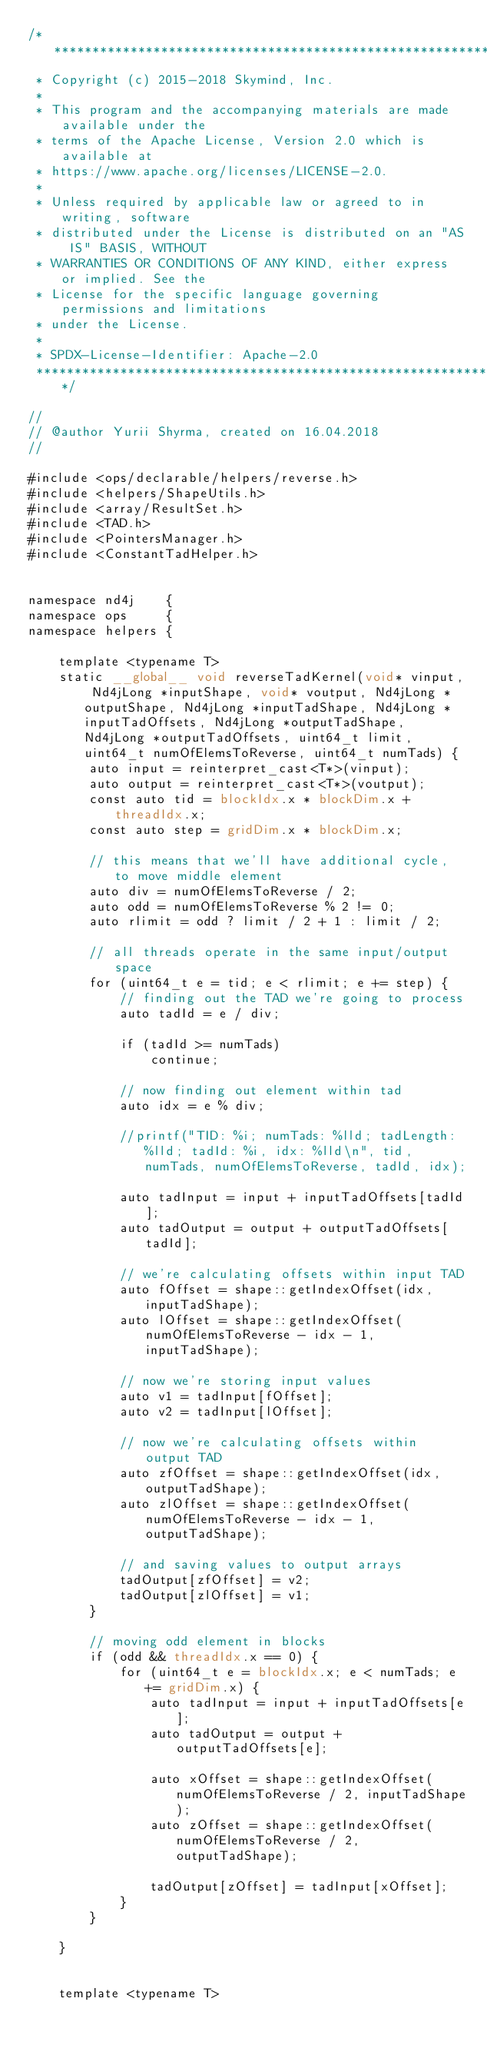<code> <loc_0><loc_0><loc_500><loc_500><_Cuda_>/*******************************************************************************
 * Copyright (c) 2015-2018 Skymind, Inc.
 *
 * This program and the accompanying materials are made available under the
 * terms of the Apache License, Version 2.0 which is available at
 * https://www.apache.org/licenses/LICENSE-2.0.
 *
 * Unless required by applicable law or agreed to in writing, software
 * distributed under the License is distributed on an "AS IS" BASIS, WITHOUT
 * WARRANTIES OR CONDITIONS OF ANY KIND, either express or implied. See the
 * License for the specific language governing permissions and limitations
 * under the License.
 *
 * SPDX-License-Identifier: Apache-2.0
 ******************************************************************************/

//
// @author Yurii Shyrma, created on 16.04.2018
//

#include <ops/declarable/helpers/reverse.h>
#include <helpers/ShapeUtils.h>
#include <array/ResultSet.h>
#include <TAD.h>
#include <PointersManager.h>
#include <ConstantTadHelper.h>


namespace nd4j    {
namespace ops     {
namespace helpers {

    template <typename T>
    static __global__ void reverseTadKernel(void* vinput, Nd4jLong *inputShape, void* voutput, Nd4jLong *outputShape, Nd4jLong *inputTadShape, Nd4jLong *inputTadOffsets, Nd4jLong *outputTadShape, Nd4jLong *outputTadOffsets, uint64_t limit, uint64_t numOfElemsToReverse, uint64_t numTads) {
        auto input = reinterpret_cast<T*>(vinput);
        auto output = reinterpret_cast<T*>(voutput);
        const auto tid = blockIdx.x * blockDim.x + threadIdx.x;
        const auto step = gridDim.x * blockDim.x;

        // this means that we'll have additional cycle, to move middle element
        auto div = numOfElemsToReverse / 2;
        auto odd = numOfElemsToReverse % 2 != 0;
        auto rlimit = odd ? limit / 2 + 1 : limit / 2;

        // all threads operate in the same input/output space
        for (uint64_t e = tid; e < rlimit; e += step) {
            // finding out the TAD we're going to process
            auto tadId = e / div;

            if (tadId >= numTads)
                continue;

            // now finding out element within tad
            auto idx = e % div;

            //printf("TID: %i; numTads: %lld; tadLength: %lld; tadId: %i, idx: %lld\n", tid, numTads, numOfElemsToReverse, tadId, idx);

            auto tadInput = input + inputTadOffsets[tadId];
            auto tadOutput = output + outputTadOffsets[tadId];

            // we're calculating offsets within input TAD
            auto fOffset = shape::getIndexOffset(idx, inputTadShape);
            auto lOffset = shape::getIndexOffset(numOfElemsToReverse - idx - 1, inputTadShape);

            // now we're storing input values
            auto v1 = tadInput[fOffset];
            auto v2 = tadInput[lOffset];

            // now we're calculating offsets within output TAD
            auto zfOffset = shape::getIndexOffset(idx, outputTadShape);
            auto zlOffset = shape::getIndexOffset(numOfElemsToReverse - idx - 1, outputTadShape);

            // and saving values to output arrays
            tadOutput[zfOffset] = v2;
            tadOutput[zlOffset] = v1;
        }

        // moving odd element in blocks
        if (odd && threadIdx.x == 0) {
            for (uint64_t e = blockIdx.x; e < numTads; e += gridDim.x) {
                auto tadInput = input + inputTadOffsets[e];
                auto tadOutput = output + outputTadOffsets[e];

                auto xOffset = shape::getIndexOffset(numOfElemsToReverse / 2, inputTadShape);
                auto zOffset = shape::getIndexOffset(numOfElemsToReverse / 2, outputTadShape);

                tadOutput[zOffset] = tadInput[xOffset];
            }
        }

    }


    template <typename T></code> 